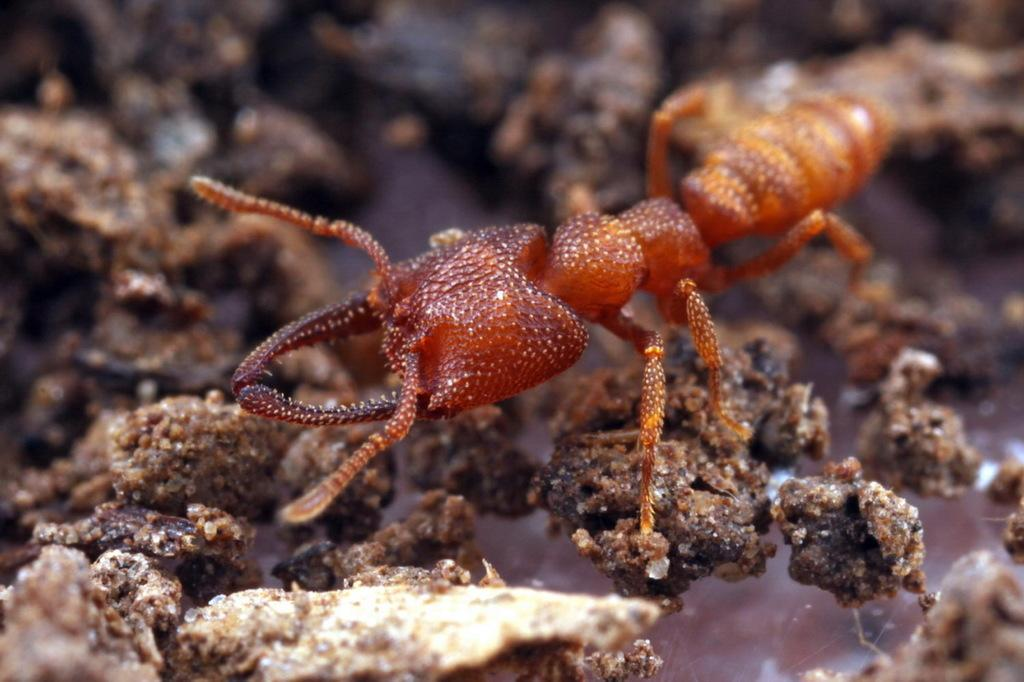What type of creature is in the image? There is a small brown insect in the image. What is the insect doing in the image? The insect is crawling on mud stones. How many wheels can be seen on the insect in the image? There are no wheels present on the insect in the image, as insects do not have wheels. What type of cat is visible in the image? There is no cat present in the image; it features a small brown insect crawling on mud stones. 